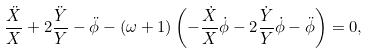Convert formula to latex. <formula><loc_0><loc_0><loc_500><loc_500>\frac { \ddot { X } } { X } + 2 \frac { \ddot { Y } } { Y } - \ddot { \phi } - ( \omega + 1 ) \left ( - \frac { \dot { X } } { X } \dot { \phi } - 2 \frac { \dot { Y } } { Y } \dot { \phi } - \ddot { \phi } \right ) = 0 ,</formula> 